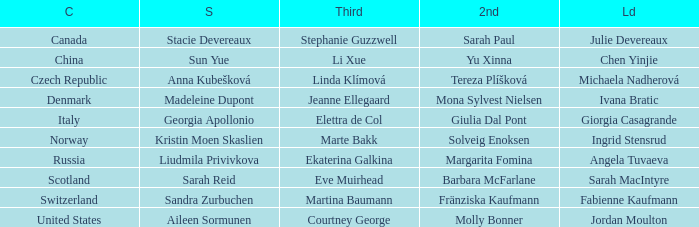What skip has norway as the country? Kristin Moen Skaslien. Parse the full table. {'header': ['C', 'S', 'Third', '2nd', 'Ld'], 'rows': [['Canada', 'Stacie Devereaux', 'Stephanie Guzzwell', 'Sarah Paul', 'Julie Devereaux'], ['China', 'Sun Yue', 'Li Xue', 'Yu Xinna', 'Chen Yinjie'], ['Czech Republic', 'Anna Kubešková', 'Linda Klímová', 'Tereza Plíšková', 'Michaela Nadherová'], ['Denmark', 'Madeleine Dupont', 'Jeanne Ellegaard', 'Mona Sylvest Nielsen', 'Ivana Bratic'], ['Italy', 'Georgia Apollonio', 'Elettra de Col', 'Giulia Dal Pont', 'Giorgia Casagrande'], ['Norway', 'Kristin Moen Skaslien', 'Marte Bakk', 'Solveig Enoksen', 'Ingrid Stensrud'], ['Russia', 'Liudmila Privivkova', 'Ekaterina Galkina', 'Margarita Fomina', 'Angela Tuvaeva'], ['Scotland', 'Sarah Reid', 'Eve Muirhead', 'Barbara McFarlane', 'Sarah MacIntyre'], ['Switzerland', 'Sandra Zurbuchen', 'Martina Baumann', 'Fränziska Kaufmann', 'Fabienne Kaufmann'], ['United States', 'Aileen Sormunen', 'Courtney George', 'Molly Bonner', 'Jordan Moulton']]} 